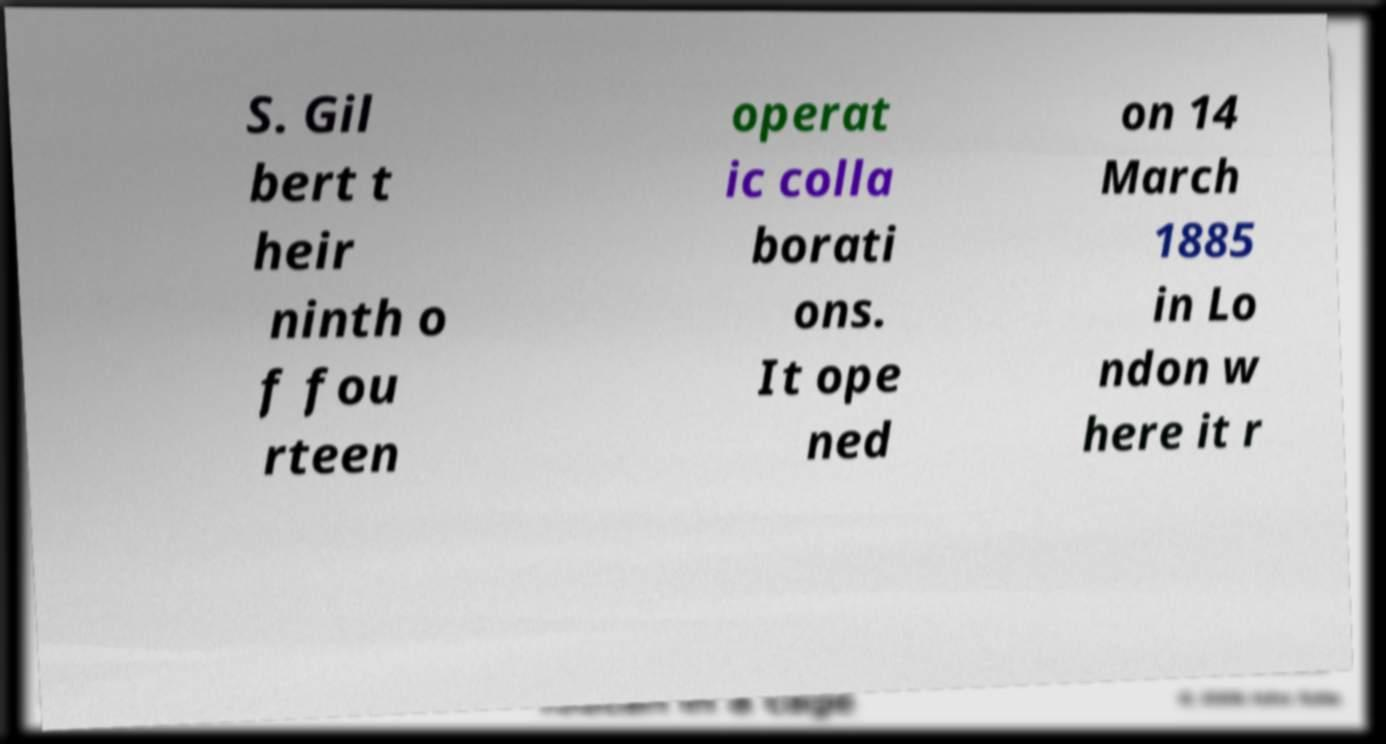What messages or text are displayed in this image? I need them in a readable, typed format. S. Gil bert t heir ninth o f fou rteen operat ic colla borati ons. It ope ned on 14 March 1885 in Lo ndon w here it r 